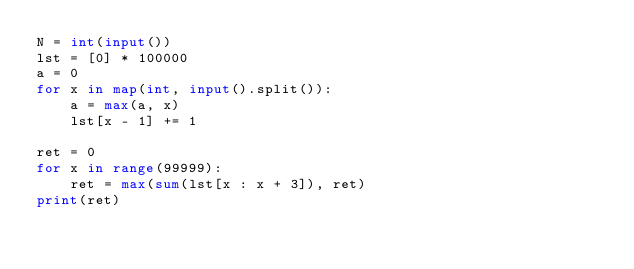<code> <loc_0><loc_0><loc_500><loc_500><_Python_>N = int(input())
lst = [0] * 100000
a = 0
for x in map(int, input().split()):
    a = max(a, x)
    lst[x - 1] += 1

ret = 0
for x in range(99999):
    ret = max(sum(lst[x : x + 3]), ret)
print(ret)
</code> 